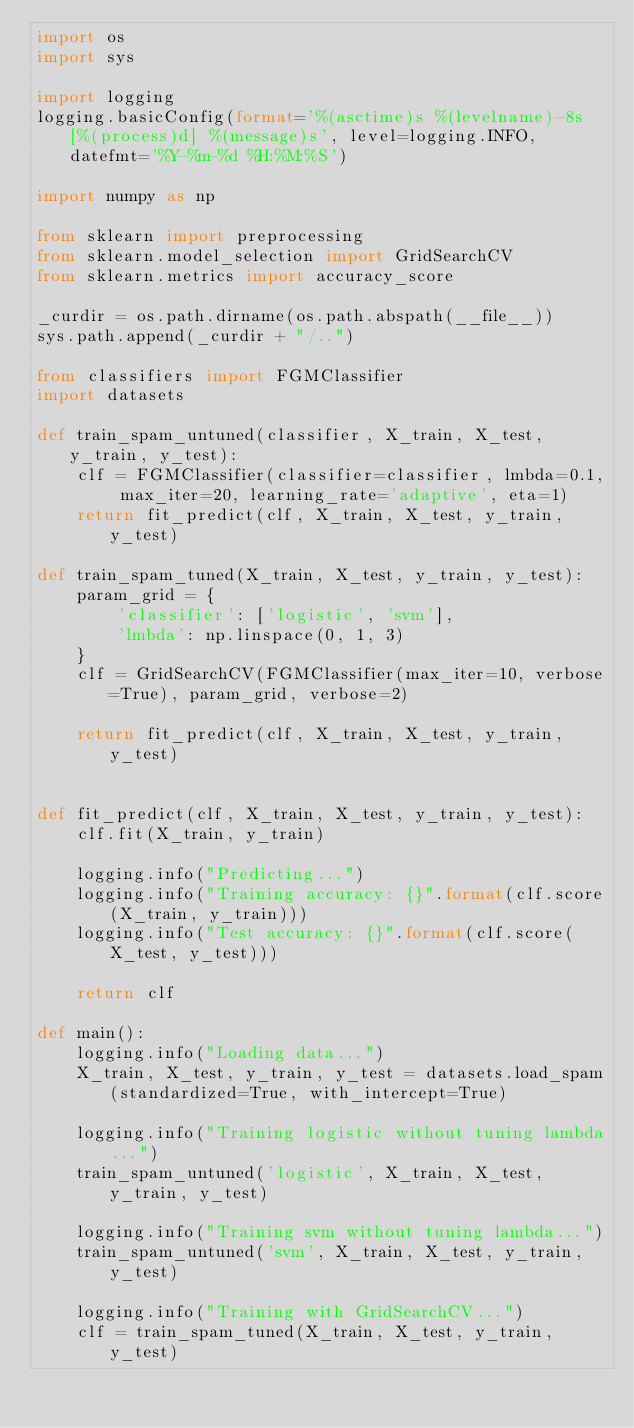<code> <loc_0><loc_0><loc_500><loc_500><_Python_>import os
import sys

import logging
logging.basicConfig(format='%(asctime)s %(levelname)-8s [%(process)d] %(message)s', level=logging.INFO, datefmt='%Y-%m-%d %H:%M:%S')

import numpy as np

from sklearn import preprocessing
from sklearn.model_selection import GridSearchCV
from sklearn.metrics import accuracy_score

_curdir = os.path.dirname(os.path.abspath(__file__))
sys.path.append(_curdir + "/..")

from classifiers import FGMClassifier
import datasets

def train_spam_untuned(classifier, X_train, X_test, y_train, y_test):
    clf = FGMClassifier(classifier=classifier, lmbda=0.1, max_iter=20, learning_rate='adaptive', eta=1)
    return fit_predict(clf, X_train, X_test, y_train, y_test)

def train_spam_tuned(X_train, X_test, y_train, y_test):
    param_grid = {
        'classifier': ['logistic', 'svm'],
        'lmbda': np.linspace(0, 1, 3)
    }
    clf = GridSearchCV(FGMClassifier(max_iter=10, verbose=True), param_grid, verbose=2)

    return fit_predict(clf, X_train, X_test, y_train, y_test)


def fit_predict(clf, X_train, X_test, y_train, y_test):
    clf.fit(X_train, y_train)

    logging.info("Predicting...")
    logging.info("Training accuracy: {}".format(clf.score(X_train, y_train)))
    logging.info("Test accuracy: {}".format(clf.score(X_test, y_test)))

    return clf

def main():
    logging.info("Loading data...")
    X_train, X_test, y_train, y_test = datasets.load_spam(standardized=True, with_intercept=True)

    logging.info("Training logistic without tuning lambda...")
    train_spam_untuned('logistic', X_train, X_test, y_train, y_test)

    logging.info("Training svm without tuning lambda...")
    train_spam_untuned('svm', X_train, X_test, y_train, y_test)

    logging.info("Training with GridSearchCV...")
    clf = train_spam_tuned(X_train, X_test, y_train, y_test)
</code> 